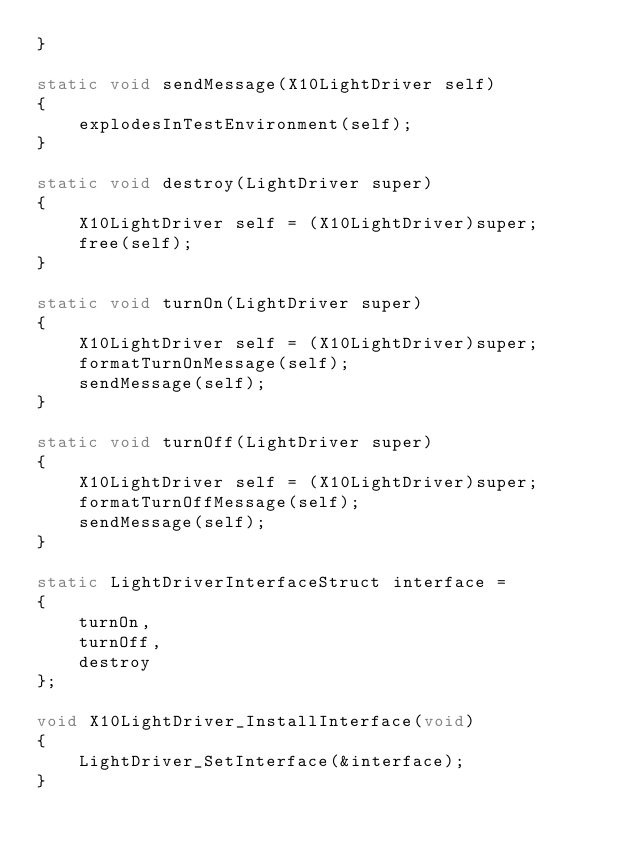Convert code to text. <code><loc_0><loc_0><loc_500><loc_500><_C_>}

static void sendMessage(X10LightDriver self)
{
    explodesInTestEnvironment(self);
}

static void destroy(LightDriver super)
{
    X10LightDriver self = (X10LightDriver)super;
    free(self);
}

static void turnOn(LightDriver super)
{
    X10LightDriver self = (X10LightDriver)super;
    formatTurnOnMessage(self);
    sendMessage(self);
}

static void turnOff(LightDriver super)
{
    X10LightDriver self = (X10LightDriver)super;
    formatTurnOffMessage(self);
    sendMessage(self);
}

static LightDriverInterfaceStruct interface =
{
    turnOn,
    turnOff,
    destroy
};

void X10LightDriver_InstallInterface(void)
{
    LightDriver_SetInterface(&interface);
}

</code> 